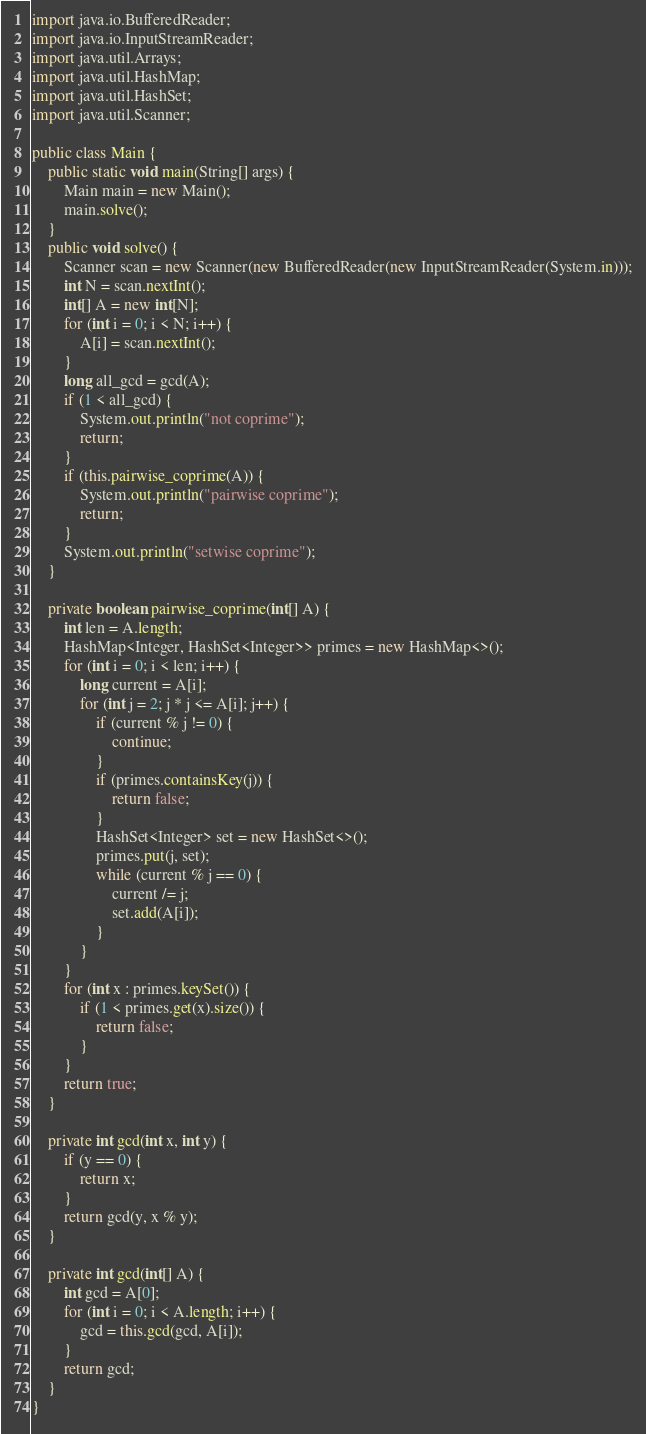Convert code to text. <code><loc_0><loc_0><loc_500><loc_500><_Java_>import java.io.BufferedReader;
import java.io.InputStreamReader;
import java.util.Arrays;
import java.util.HashMap;
import java.util.HashSet;
import java.util.Scanner;

public class Main {
    public static void main(String[] args) {
        Main main = new Main();
        main.solve();
    }
    public void solve() {
        Scanner scan = new Scanner(new BufferedReader(new InputStreamReader(System.in)));
        int N = scan.nextInt();
        int[] A = new int[N];
        for (int i = 0; i < N; i++) {
            A[i] = scan.nextInt();
        }
        long all_gcd = gcd(A);
        if (1 < all_gcd) {
            System.out.println("not coprime");
            return;
        }
        if (this.pairwise_coprime(A)) {
            System.out.println("pairwise coprime");
            return;
        }
        System.out.println("setwise coprime");
    }

    private boolean pairwise_coprime(int[] A) {
        int len = A.length;
        HashMap<Integer, HashSet<Integer>> primes = new HashMap<>();
        for (int i = 0; i < len; i++) {
            long current = A[i];
            for (int j = 2; j * j <= A[i]; j++) {
                if (current % j != 0) {
                    continue;
                }
                if (primes.containsKey(j)) {
                    return false;
                }
                HashSet<Integer> set = new HashSet<>();
                primes.put(j, set);
                while (current % j == 0) {
                    current /= j;
                    set.add(A[i]);
                }
            }
        }
        for (int x : primes.keySet()) {
            if (1 < primes.get(x).size()) {
                return false;
            }
        }
        return true;
    }

    private int gcd(int x, int y) {
        if (y == 0) {
            return x;
        }
        return gcd(y, x % y);
    }

    private int gcd(int[] A) {
        int gcd = A[0];
        for (int i = 0; i < A.length; i++) {
            gcd = this.gcd(gcd, A[i]);
        }
        return gcd;
    }
}
</code> 